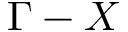Convert formula to latex. <formula><loc_0><loc_0><loc_500><loc_500>\Gamma - X</formula> 